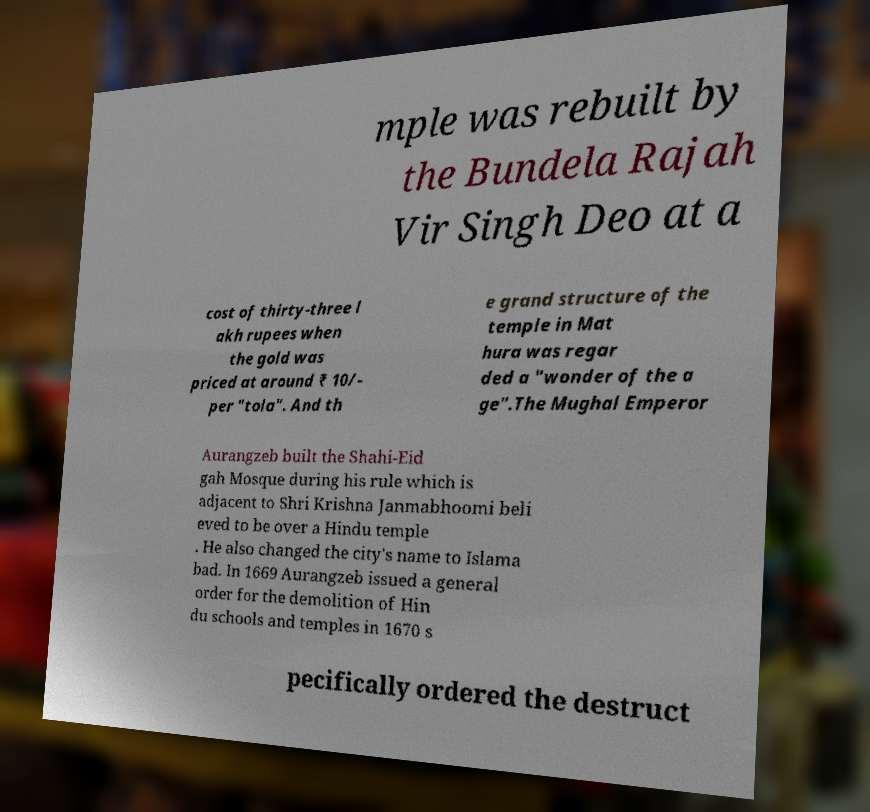Please read and relay the text visible in this image. What does it say? mple was rebuilt by the Bundela Rajah Vir Singh Deo at a cost of thirty-three l akh rupees when the gold was priced at around ₹ 10/- per "tola". And th e grand structure of the temple in Mat hura was regar ded a "wonder of the a ge".The Mughal Emperor Aurangzeb built the Shahi-Eid gah Mosque during his rule which is adjacent to Shri Krishna Janmabhoomi beli eved to be over a Hindu temple . He also changed the city's name to Islama bad. In 1669 Aurangzeb issued a general order for the demolition of Hin du schools and temples in 1670 s pecifically ordered the destruct 